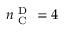<formula> <loc_0><loc_0><loc_500><loc_500>n _ { C } ^ { D } = 4</formula> 